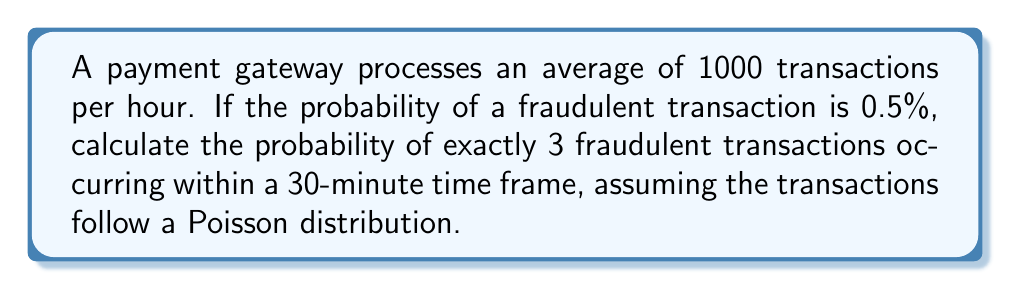Could you help me with this problem? To solve this problem, we need to use the Poisson distribution, which is appropriate for modeling the number of events occurring in a fixed interval of time when these events happen with a known average rate.

Let's break down the problem and solve it step-by-step:

1. Calculate the average number of transactions in 30 minutes:
   $$\lambda = 1000 \text{ transactions/hour} \times 0.5 \text{ hours} = 500 \text{ transactions}$$

2. Calculate the average number of fraudulent transactions in 30 minutes:
   $$\lambda_f = 500 \text{ transactions} \times 0.005 = 2.5 \text{ fraudulent transactions}$$

3. Use the Poisson probability mass function to calculate the probability of exactly 3 fraudulent transactions:
   $$P(X = k) = \frac{e^{-\lambda} \lambda^k}{k!}$$
   
   Where:
   $\lambda = 2.5$ (average number of fraudulent transactions)
   $k = 3$ (number of fraudulent transactions we're interested in)

4. Plug in the values:
   $$P(X = 3) = \frac{e^{-2.5} (2.5)^3}{3!}$$

5. Calculate:
   $$P(X = 3) = \frac{e^{-2.5} \times 15.625}{6}$$
   $$P(X = 3) = \frac{0.082085 \times 15.625}{6}$$
   $$P(X = 3) = 0.2134$$

Therefore, the probability of exactly 3 fraudulent transactions occurring within a 30-minute time frame is approximately 0.2134 or 21.34%.
Answer: $0.2134$ or $21.34\%$ 